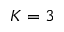Convert formula to latex. <formula><loc_0><loc_0><loc_500><loc_500>K = 3</formula> 